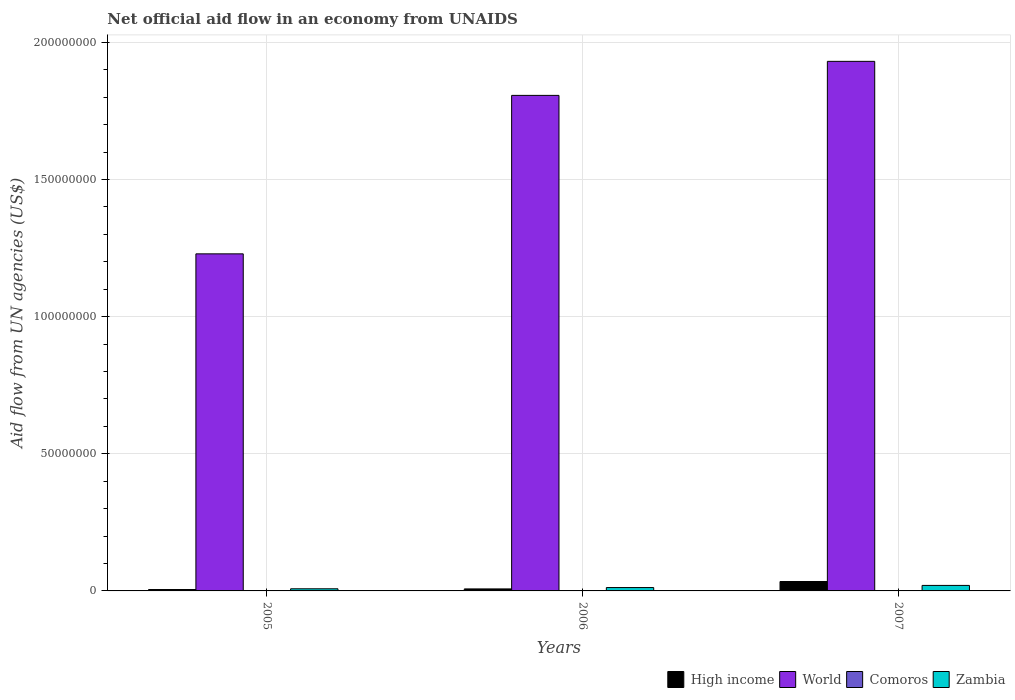How many different coloured bars are there?
Keep it short and to the point. 4. How many groups of bars are there?
Provide a succinct answer. 3. Are the number of bars on each tick of the X-axis equal?
Your answer should be compact. Yes. How many bars are there on the 2nd tick from the right?
Your response must be concise. 4. What is the label of the 2nd group of bars from the left?
Provide a succinct answer. 2006. What is the net official aid flow in Zambia in 2005?
Keep it short and to the point. 7.80e+05. Across all years, what is the maximum net official aid flow in High income?
Your answer should be very brief. 3.43e+06. Across all years, what is the minimum net official aid flow in Zambia?
Provide a succinct answer. 7.80e+05. In which year was the net official aid flow in High income maximum?
Keep it short and to the point. 2007. What is the total net official aid flow in High income in the graph?
Give a very brief answer. 4.67e+06. What is the difference between the net official aid flow in World in 2007 and the net official aid flow in Zambia in 2005?
Offer a terse response. 1.92e+08. What is the average net official aid flow in Comoros per year?
Provide a succinct answer. 7.00e+04. In the year 2007, what is the difference between the net official aid flow in World and net official aid flow in Zambia?
Keep it short and to the point. 1.91e+08. In how many years, is the net official aid flow in Comoros greater than 140000000 US$?
Offer a terse response. 0. What is the ratio of the net official aid flow in High income in 2005 to that in 2007?
Give a very brief answer. 0.15. Is the net official aid flow in World in 2005 less than that in 2006?
Offer a very short reply. Yes. Is the difference between the net official aid flow in World in 2005 and 2006 greater than the difference between the net official aid flow in Zambia in 2005 and 2006?
Offer a very short reply. No. What is the difference between the highest and the second highest net official aid flow in Zambia?
Offer a very short reply. 7.80e+05. In how many years, is the net official aid flow in High income greater than the average net official aid flow in High income taken over all years?
Give a very brief answer. 1. Is it the case that in every year, the sum of the net official aid flow in Comoros and net official aid flow in Zambia is greater than the net official aid flow in World?
Make the answer very short. No. How many bars are there?
Make the answer very short. 12. Are all the bars in the graph horizontal?
Keep it short and to the point. No. What is the difference between two consecutive major ticks on the Y-axis?
Keep it short and to the point. 5.00e+07. Are the values on the major ticks of Y-axis written in scientific E-notation?
Your answer should be compact. No. How are the legend labels stacked?
Provide a short and direct response. Horizontal. What is the title of the graph?
Keep it short and to the point. Net official aid flow in an economy from UNAIDS. Does "Bolivia" appear as one of the legend labels in the graph?
Make the answer very short. No. What is the label or title of the Y-axis?
Make the answer very short. Aid flow from UN agencies (US$). What is the Aid flow from UN agencies (US$) in High income in 2005?
Offer a very short reply. 5.10e+05. What is the Aid flow from UN agencies (US$) of World in 2005?
Keep it short and to the point. 1.23e+08. What is the Aid flow from UN agencies (US$) of Zambia in 2005?
Provide a succinct answer. 7.80e+05. What is the Aid flow from UN agencies (US$) in High income in 2006?
Offer a very short reply. 7.30e+05. What is the Aid flow from UN agencies (US$) in World in 2006?
Ensure brevity in your answer.  1.81e+08. What is the Aid flow from UN agencies (US$) in Comoros in 2006?
Your answer should be compact. 2.00e+04. What is the Aid flow from UN agencies (US$) in Zambia in 2006?
Provide a succinct answer. 1.23e+06. What is the Aid flow from UN agencies (US$) in High income in 2007?
Offer a very short reply. 3.43e+06. What is the Aid flow from UN agencies (US$) of World in 2007?
Your response must be concise. 1.93e+08. What is the Aid flow from UN agencies (US$) in Comoros in 2007?
Your answer should be very brief. 1.40e+05. What is the Aid flow from UN agencies (US$) of Zambia in 2007?
Give a very brief answer. 2.01e+06. Across all years, what is the maximum Aid flow from UN agencies (US$) of High income?
Offer a terse response. 3.43e+06. Across all years, what is the maximum Aid flow from UN agencies (US$) of World?
Offer a very short reply. 1.93e+08. Across all years, what is the maximum Aid flow from UN agencies (US$) in Comoros?
Your answer should be compact. 1.40e+05. Across all years, what is the maximum Aid flow from UN agencies (US$) of Zambia?
Offer a terse response. 2.01e+06. Across all years, what is the minimum Aid flow from UN agencies (US$) in High income?
Offer a very short reply. 5.10e+05. Across all years, what is the minimum Aid flow from UN agencies (US$) of World?
Your answer should be compact. 1.23e+08. Across all years, what is the minimum Aid flow from UN agencies (US$) of Comoros?
Provide a succinct answer. 2.00e+04. Across all years, what is the minimum Aid flow from UN agencies (US$) in Zambia?
Offer a terse response. 7.80e+05. What is the total Aid flow from UN agencies (US$) of High income in the graph?
Provide a succinct answer. 4.67e+06. What is the total Aid flow from UN agencies (US$) in World in the graph?
Your response must be concise. 4.97e+08. What is the total Aid flow from UN agencies (US$) of Zambia in the graph?
Provide a short and direct response. 4.02e+06. What is the difference between the Aid flow from UN agencies (US$) of World in 2005 and that in 2006?
Ensure brevity in your answer.  -5.78e+07. What is the difference between the Aid flow from UN agencies (US$) in Zambia in 2005 and that in 2006?
Give a very brief answer. -4.50e+05. What is the difference between the Aid flow from UN agencies (US$) in High income in 2005 and that in 2007?
Make the answer very short. -2.92e+06. What is the difference between the Aid flow from UN agencies (US$) in World in 2005 and that in 2007?
Give a very brief answer. -7.02e+07. What is the difference between the Aid flow from UN agencies (US$) of Comoros in 2005 and that in 2007?
Provide a succinct answer. -9.00e+04. What is the difference between the Aid flow from UN agencies (US$) in Zambia in 2005 and that in 2007?
Your response must be concise. -1.23e+06. What is the difference between the Aid flow from UN agencies (US$) of High income in 2006 and that in 2007?
Keep it short and to the point. -2.70e+06. What is the difference between the Aid flow from UN agencies (US$) of World in 2006 and that in 2007?
Make the answer very short. -1.24e+07. What is the difference between the Aid flow from UN agencies (US$) in Comoros in 2006 and that in 2007?
Give a very brief answer. -1.20e+05. What is the difference between the Aid flow from UN agencies (US$) of Zambia in 2006 and that in 2007?
Your answer should be very brief. -7.80e+05. What is the difference between the Aid flow from UN agencies (US$) in High income in 2005 and the Aid flow from UN agencies (US$) in World in 2006?
Provide a succinct answer. -1.80e+08. What is the difference between the Aid flow from UN agencies (US$) in High income in 2005 and the Aid flow from UN agencies (US$) in Comoros in 2006?
Ensure brevity in your answer.  4.90e+05. What is the difference between the Aid flow from UN agencies (US$) of High income in 2005 and the Aid flow from UN agencies (US$) of Zambia in 2006?
Give a very brief answer. -7.20e+05. What is the difference between the Aid flow from UN agencies (US$) of World in 2005 and the Aid flow from UN agencies (US$) of Comoros in 2006?
Give a very brief answer. 1.23e+08. What is the difference between the Aid flow from UN agencies (US$) in World in 2005 and the Aid flow from UN agencies (US$) in Zambia in 2006?
Your answer should be compact. 1.22e+08. What is the difference between the Aid flow from UN agencies (US$) of Comoros in 2005 and the Aid flow from UN agencies (US$) of Zambia in 2006?
Provide a short and direct response. -1.18e+06. What is the difference between the Aid flow from UN agencies (US$) in High income in 2005 and the Aid flow from UN agencies (US$) in World in 2007?
Your answer should be compact. -1.93e+08. What is the difference between the Aid flow from UN agencies (US$) in High income in 2005 and the Aid flow from UN agencies (US$) in Comoros in 2007?
Make the answer very short. 3.70e+05. What is the difference between the Aid flow from UN agencies (US$) of High income in 2005 and the Aid flow from UN agencies (US$) of Zambia in 2007?
Give a very brief answer. -1.50e+06. What is the difference between the Aid flow from UN agencies (US$) of World in 2005 and the Aid flow from UN agencies (US$) of Comoros in 2007?
Your answer should be compact. 1.23e+08. What is the difference between the Aid flow from UN agencies (US$) in World in 2005 and the Aid flow from UN agencies (US$) in Zambia in 2007?
Offer a very short reply. 1.21e+08. What is the difference between the Aid flow from UN agencies (US$) of Comoros in 2005 and the Aid flow from UN agencies (US$) of Zambia in 2007?
Provide a short and direct response. -1.96e+06. What is the difference between the Aid flow from UN agencies (US$) in High income in 2006 and the Aid flow from UN agencies (US$) in World in 2007?
Offer a terse response. -1.92e+08. What is the difference between the Aid flow from UN agencies (US$) in High income in 2006 and the Aid flow from UN agencies (US$) in Comoros in 2007?
Your response must be concise. 5.90e+05. What is the difference between the Aid flow from UN agencies (US$) in High income in 2006 and the Aid flow from UN agencies (US$) in Zambia in 2007?
Your answer should be compact. -1.28e+06. What is the difference between the Aid flow from UN agencies (US$) of World in 2006 and the Aid flow from UN agencies (US$) of Comoros in 2007?
Your answer should be very brief. 1.81e+08. What is the difference between the Aid flow from UN agencies (US$) of World in 2006 and the Aid flow from UN agencies (US$) of Zambia in 2007?
Ensure brevity in your answer.  1.79e+08. What is the difference between the Aid flow from UN agencies (US$) in Comoros in 2006 and the Aid flow from UN agencies (US$) in Zambia in 2007?
Offer a terse response. -1.99e+06. What is the average Aid flow from UN agencies (US$) of High income per year?
Keep it short and to the point. 1.56e+06. What is the average Aid flow from UN agencies (US$) of World per year?
Make the answer very short. 1.66e+08. What is the average Aid flow from UN agencies (US$) in Zambia per year?
Offer a terse response. 1.34e+06. In the year 2005, what is the difference between the Aid flow from UN agencies (US$) in High income and Aid flow from UN agencies (US$) in World?
Keep it short and to the point. -1.22e+08. In the year 2005, what is the difference between the Aid flow from UN agencies (US$) in High income and Aid flow from UN agencies (US$) in Comoros?
Provide a succinct answer. 4.60e+05. In the year 2005, what is the difference between the Aid flow from UN agencies (US$) in World and Aid flow from UN agencies (US$) in Comoros?
Ensure brevity in your answer.  1.23e+08. In the year 2005, what is the difference between the Aid flow from UN agencies (US$) of World and Aid flow from UN agencies (US$) of Zambia?
Your response must be concise. 1.22e+08. In the year 2005, what is the difference between the Aid flow from UN agencies (US$) of Comoros and Aid flow from UN agencies (US$) of Zambia?
Make the answer very short. -7.30e+05. In the year 2006, what is the difference between the Aid flow from UN agencies (US$) in High income and Aid flow from UN agencies (US$) in World?
Make the answer very short. -1.80e+08. In the year 2006, what is the difference between the Aid flow from UN agencies (US$) in High income and Aid flow from UN agencies (US$) in Comoros?
Offer a terse response. 7.10e+05. In the year 2006, what is the difference between the Aid flow from UN agencies (US$) of High income and Aid flow from UN agencies (US$) of Zambia?
Provide a succinct answer. -5.00e+05. In the year 2006, what is the difference between the Aid flow from UN agencies (US$) of World and Aid flow from UN agencies (US$) of Comoros?
Ensure brevity in your answer.  1.81e+08. In the year 2006, what is the difference between the Aid flow from UN agencies (US$) in World and Aid flow from UN agencies (US$) in Zambia?
Make the answer very short. 1.79e+08. In the year 2006, what is the difference between the Aid flow from UN agencies (US$) of Comoros and Aid flow from UN agencies (US$) of Zambia?
Your response must be concise. -1.21e+06. In the year 2007, what is the difference between the Aid flow from UN agencies (US$) of High income and Aid flow from UN agencies (US$) of World?
Your answer should be very brief. -1.90e+08. In the year 2007, what is the difference between the Aid flow from UN agencies (US$) in High income and Aid flow from UN agencies (US$) in Comoros?
Make the answer very short. 3.29e+06. In the year 2007, what is the difference between the Aid flow from UN agencies (US$) in High income and Aid flow from UN agencies (US$) in Zambia?
Ensure brevity in your answer.  1.42e+06. In the year 2007, what is the difference between the Aid flow from UN agencies (US$) in World and Aid flow from UN agencies (US$) in Comoros?
Make the answer very short. 1.93e+08. In the year 2007, what is the difference between the Aid flow from UN agencies (US$) of World and Aid flow from UN agencies (US$) of Zambia?
Provide a short and direct response. 1.91e+08. In the year 2007, what is the difference between the Aid flow from UN agencies (US$) of Comoros and Aid flow from UN agencies (US$) of Zambia?
Offer a terse response. -1.87e+06. What is the ratio of the Aid flow from UN agencies (US$) of High income in 2005 to that in 2006?
Offer a very short reply. 0.7. What is the ratio of the Aid flow from UN agencies (US$) in World in 2005 to that in 2006?
Offer a very short reply. 0.68. What is the ratio of the Aid flow from UN agencies (US$) of Zambia in 2005 to that in 2006?
Ensure brevity in your answer.  0.63. What is the ratio of the Aid flow from UN agencies (US$) in High income in 2005 to that in 2007?
Provide a short and direct response. 0.15. What is the ratio of the Aid flow from UN agencies (US$) in World in 2005 to that in 2007?
Your answer should be very brief. 0.64. What is the ratio of the Aid flow from UN agencies (US$) in Comoros in 2005 to that in 2007?
Give a very brief answer. 0.36. What is the ratio of the Aid flow from UN agencies (US$) in Zambia in 2005 to that in 2007?
Keep it short and to the point. 0.39. What is the ratio of the Aid flow from UN agencies (US$) of High income in 2006 to that in 2007?
Offer a very short reply. 0.21. What is the ratio of the Aid flow from UN agencies (US$) in World in 2006 to that in 2007?
Make the answer very short. 0.94. What is the ratio of the Aid flow from UN agencies (US$) in Comoros in 2006 to that in 2007?
Ensure brevity in your answer.  0.14. What is the ratio of the Aid flow from UN agencies (US$) in Zambia in 2006 to that in 2007?
Give a very brief answer. 0.61. What is the difference between the highest and the second highest Aid flow from UN agencies (US$) in High income?
Your answer should be compact. 2.70e+06. What is the difference between the highest and the second highest Aid flow from UN agencies (US$) of World?
Ensure brevity in your answer.  1.24e+07. What is the difference between the highest and the second highest Aid flow from UN agencies (US$) of Comoros?
Provide a short and direct response. 9.00e+04. What is the difference between the highest and the second highest Aid flow from UN agencies (US$) in Zambia?
Make the answer very short. 7.80e+05. What is the difference between the highest and the lowest Aid flow from UN agencies (US$) of High income?
Your answer should be compact. 2.92e+06. What is the difference between the highest and the lowest Aid flow from UN agencies (US$) of World?
Provide a succinct answer. 7.02e+07. What is the difference between the highest and the lowest Aid flow from UN agencies (US$) in Comoros?
Provide a succinct answer. 1.20e+05. What is the difference between the highest and the lowest Aid flow from UN agencies (US$) in Zambia?
Offer a very short reply. 1.23e+06. 